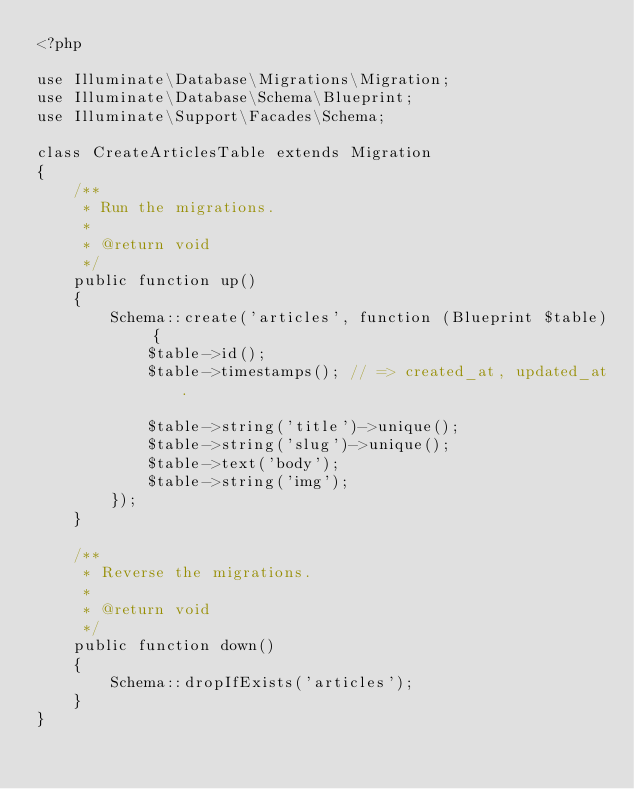<code> <loc_0><loc_0><loc_500><loc_500><_PHP_><?php

use Illuminate\Database\Migrations\Migration;
use Illuminate\Database\Schema\Blueprint;
use Illuminate\Support\Facades\Schema;

class CreateArticlesTable extends Migration
{
    /**
     * Run the migrations.
     *
     * @return void
     */
    public function up()
    {
        Schema::create('articles', function (Blueprint $table) {
            $table->id();
            $table->timestamps(); // => created_at, updated_at. 

            $table->string('title')->unique();
            $table->string('slug')->unique();
            $table->text('body');
            $table->string('img');
        });
    }

    /**
     * Reverse the migrations.
     *
     * @return void
     */
    public function down()
    {
        Schema::dropIfExists('articles');
    }
}
</code> 